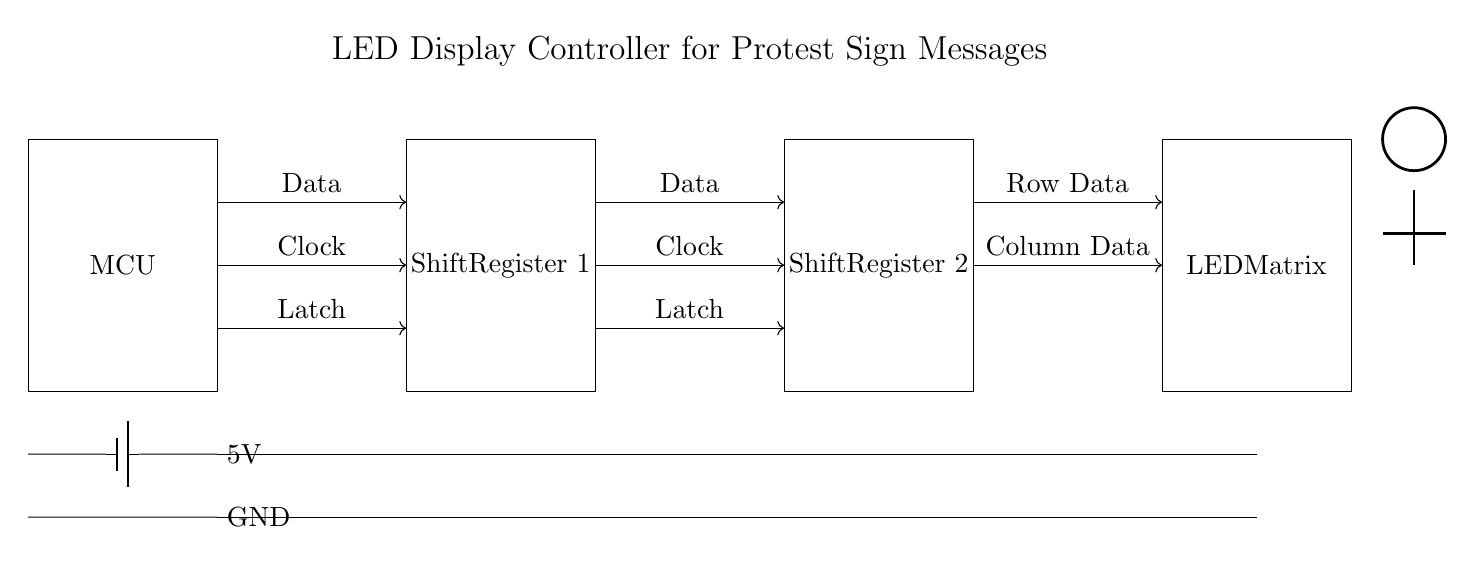What is the purpose of the microcontroller? The microcontroller (MCU) is central to the circuit, managing the data sending to the shift registers and controlling the overall operation by processing input and output signals.
Answer: Data management What is the voltage supply for the circuit? The circuit is powered by a 5V supply, as indicated by the battery symbol connected to the microcontroller. This voltage is consistent throughout the circuit, ensuring proper operation of all components.
Answer: 5V How many shift registers are present in the circuit? There are two shift registers shown in the diagram, denoted as Shift Register 1 and Shift Register 2, which help in serial data transfer to drive the LED matrix for displaying messages.
Answer: Two What do the arrows between components signify? The arrows indicate the direction of signal flow, showing how data, clock, and latch signals travel from the microcontroller to the shift registers and then to the LED matrix.
Answer: Signal flow What type of circuit is represented in this diagram? This circuit is a digital circuit used primarily for controlling LED displays, employed in projects that require dynamic message display, such as protest signs.
Answer: Digital circuit How are the components powered? All components share a common power and ground connections that are connected in parallel, ensuring each has access to the same 5V and ground potential for operation.
Answer: Parallel connections What is connected to the LED matrix? The circuit diagram indicates that both Row Data and Column Data are connected to the LED matrix from the shift registers to control individual LEDs for displaying messages.
Answer: Row and Column Data 